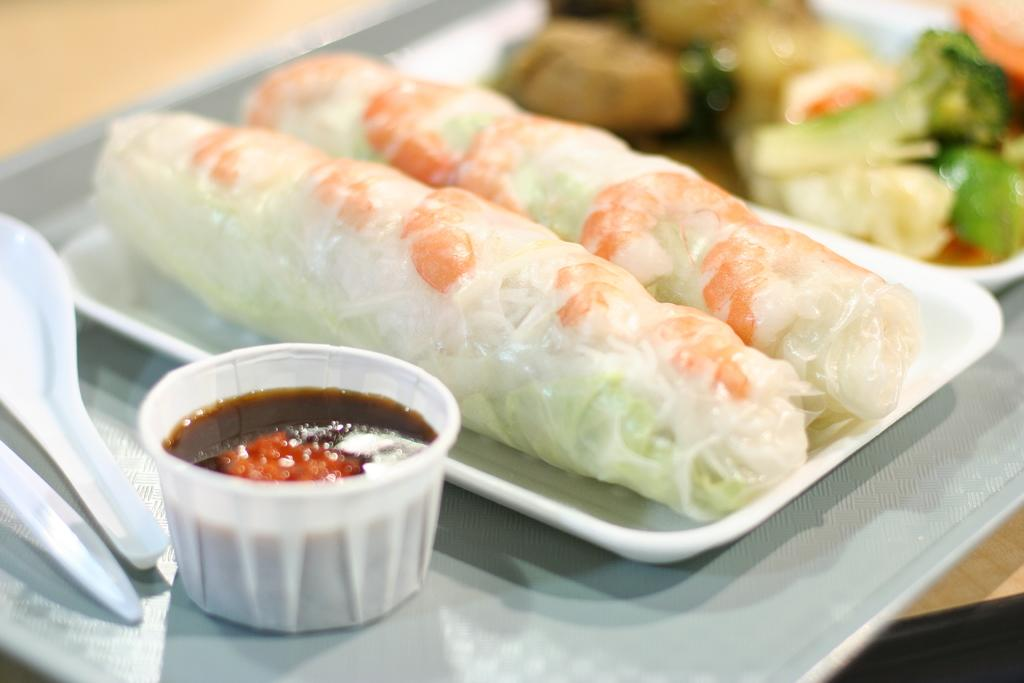What is on the plate that is visible in the image? There is food on a plate in the image. What utensil is present in the image? There is a spoon in the image. What is in the bowl that is visible in the image? There is a bowl with sauce in the image. Where is the plate located in the image? The plate is on a table in the image. Can you tell me how many people are driving in the image? There is no reference to driving or any vehicles in the image, so it is not possible to answer that question. 